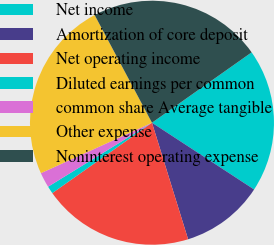Convert chart to OTSL. <chart><loc_0><loc_0><loc_500><loc_500><pie_chart><fcel>Net income<fcel>Amortization of core deposit<fcel>Net operating income<fcel>Diluted earnings per common<fcel>common share Average tangible<fcel>Other expense<fcel>Noninterest operating expense<nl><fcel>19.0%<fcel>11.0%<fcel>20.0%<fcel>1.0%<fcel>2.0%<fcel>24.0%<fcel>23.0%<nl></chart> 